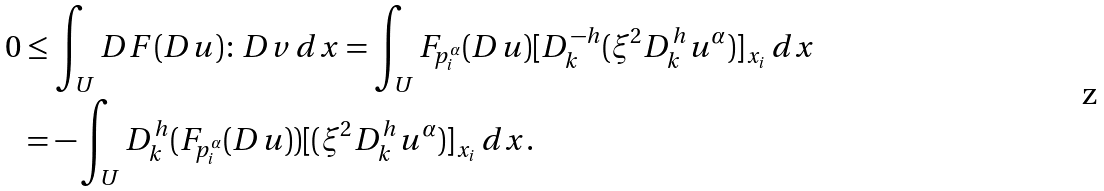<formula> <loc_0><loc_0><loc_500><loc_500>0 & \leq \int _ { U } D F ( D u ) \colon D v \, d x = \int _ { U } F _ { p _ { i } ^ { \alpha } } ( D u ) [ D _ { k } ^ { - h } ( \xi ^ { 2 } D _ { k } ^ { h } u ^ { \alpha } ) ] _ { x _ { i } } \, d x \\ & = - \int _ { U } D _ { k } ^ { h } ( F _ { p _ { i } ^ { \alpha } } ( D u ) ) [ ( \xi ^ { 2 } D _ { k } ^ { h } u ^ { \alpha } ) ] _ { x _ { i } } \, d x .</formula> 